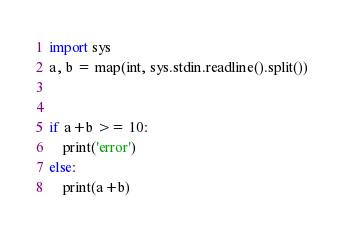<code> <loc_0><loc_0><loc_500><loc_500><_Python_>import sys
a, b = map(int, sys.stdin.readline().split())


if a+b >= 10:
    print('error')
else:
    print(a+b)</code> 